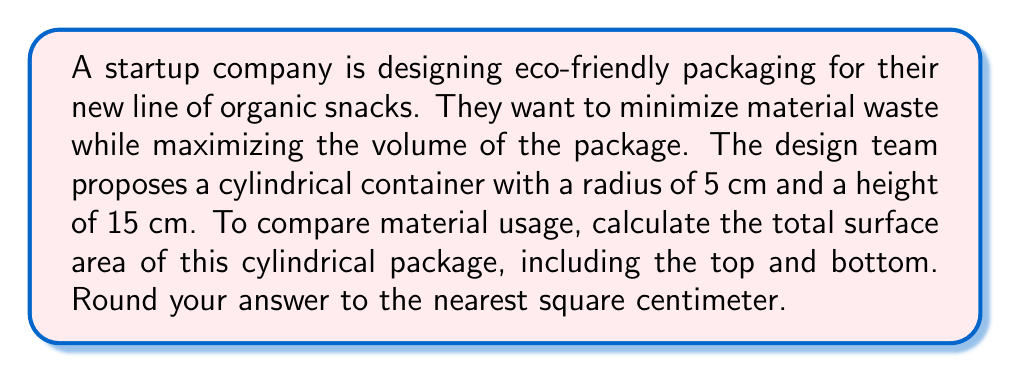Can you solve this math problem? Let's approach this step-by-step:

1) For a cylinder, we need to calculate:
   a) The area of the circular top and bottom
   b) The area of the rectangular side

2) Area of a circle: $A = \pi r^2$
   For the top and bottom: $A_{circle} = \pi (5\text{ cm})^2 = 25\pi\text{ cm}^2$
   We have two circular ends, so: $A_{ends} = 2(25\pi)\text{ cm}^2 = 50\pi\text{ cm}^2$

3) Area of the rectangular side:
   The width of this rectangle is the circumference of the circle: $2\pi r$
   The height is the height of the cylinder: $h$
   $A_{side} = 2\pi r \cdot h = 2\pi(5\text{ cm})(15\text{ cm}) = 150\pi\text{ cm}^2$

4) Total surface area:
   $A_{total} = A_{ends} + A_{side} = 50\pi\text{ cm}^2 + 150\pi\text{ cm}^2 = 200\pi\text{ cm}^2$

5) Calculate and round to the nearest cm²:
   $200\pi \approx 628.32\text{ cm}^2$
   Rounded to the nearest cm²: $628\text{ cm}^2$

This calculation allows the startup to quantify the amount of material needed for each package, crucial for cost estimation and minimizing waste in their eco-friendly initiative.
Answer: $628\text{ cm}^2$ 